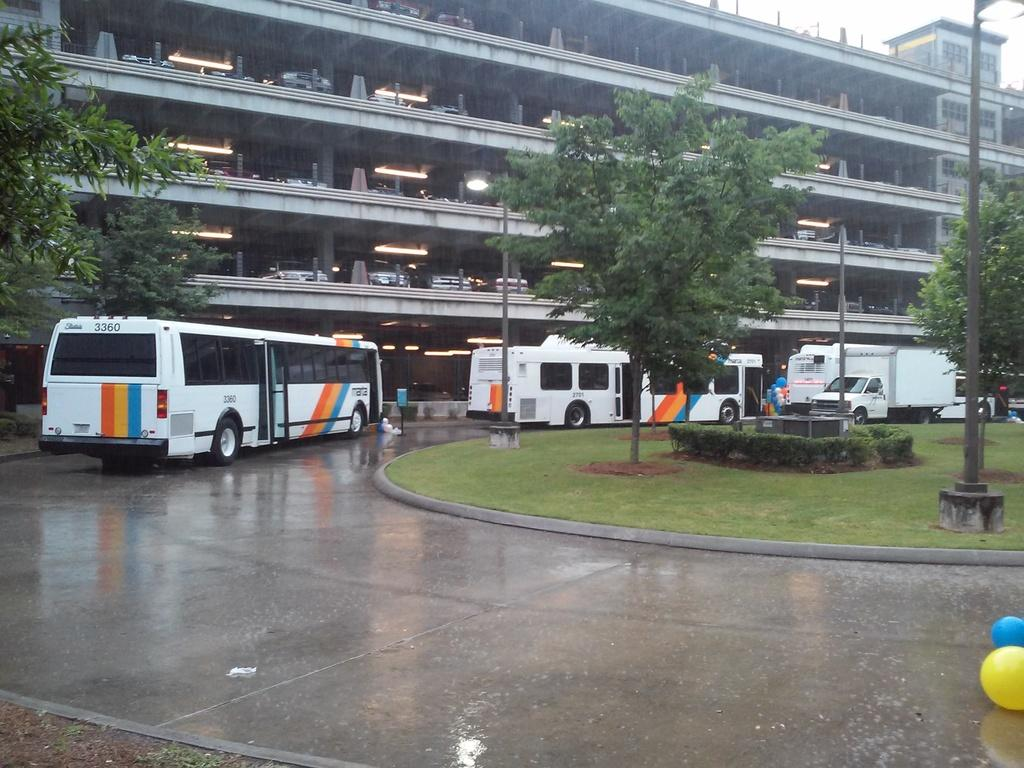What can be seen on the road in the image? There are balloons on the road. What type of vegetation is visible in the image? There is grass, plants, and trees visible in the image. What structures are present in the background of the image? There are vehicles, more balloons, a building, and additional lights in the background. What part of the natural environment is visible in the image? The sky is visible in the background of the image. How many weeks does it take for the balloons to reach the building in the image? The image does not provide information about the duration of time it takes for the balloons to reach the building, nor does it suggest that the balloons are moving towards the building. 